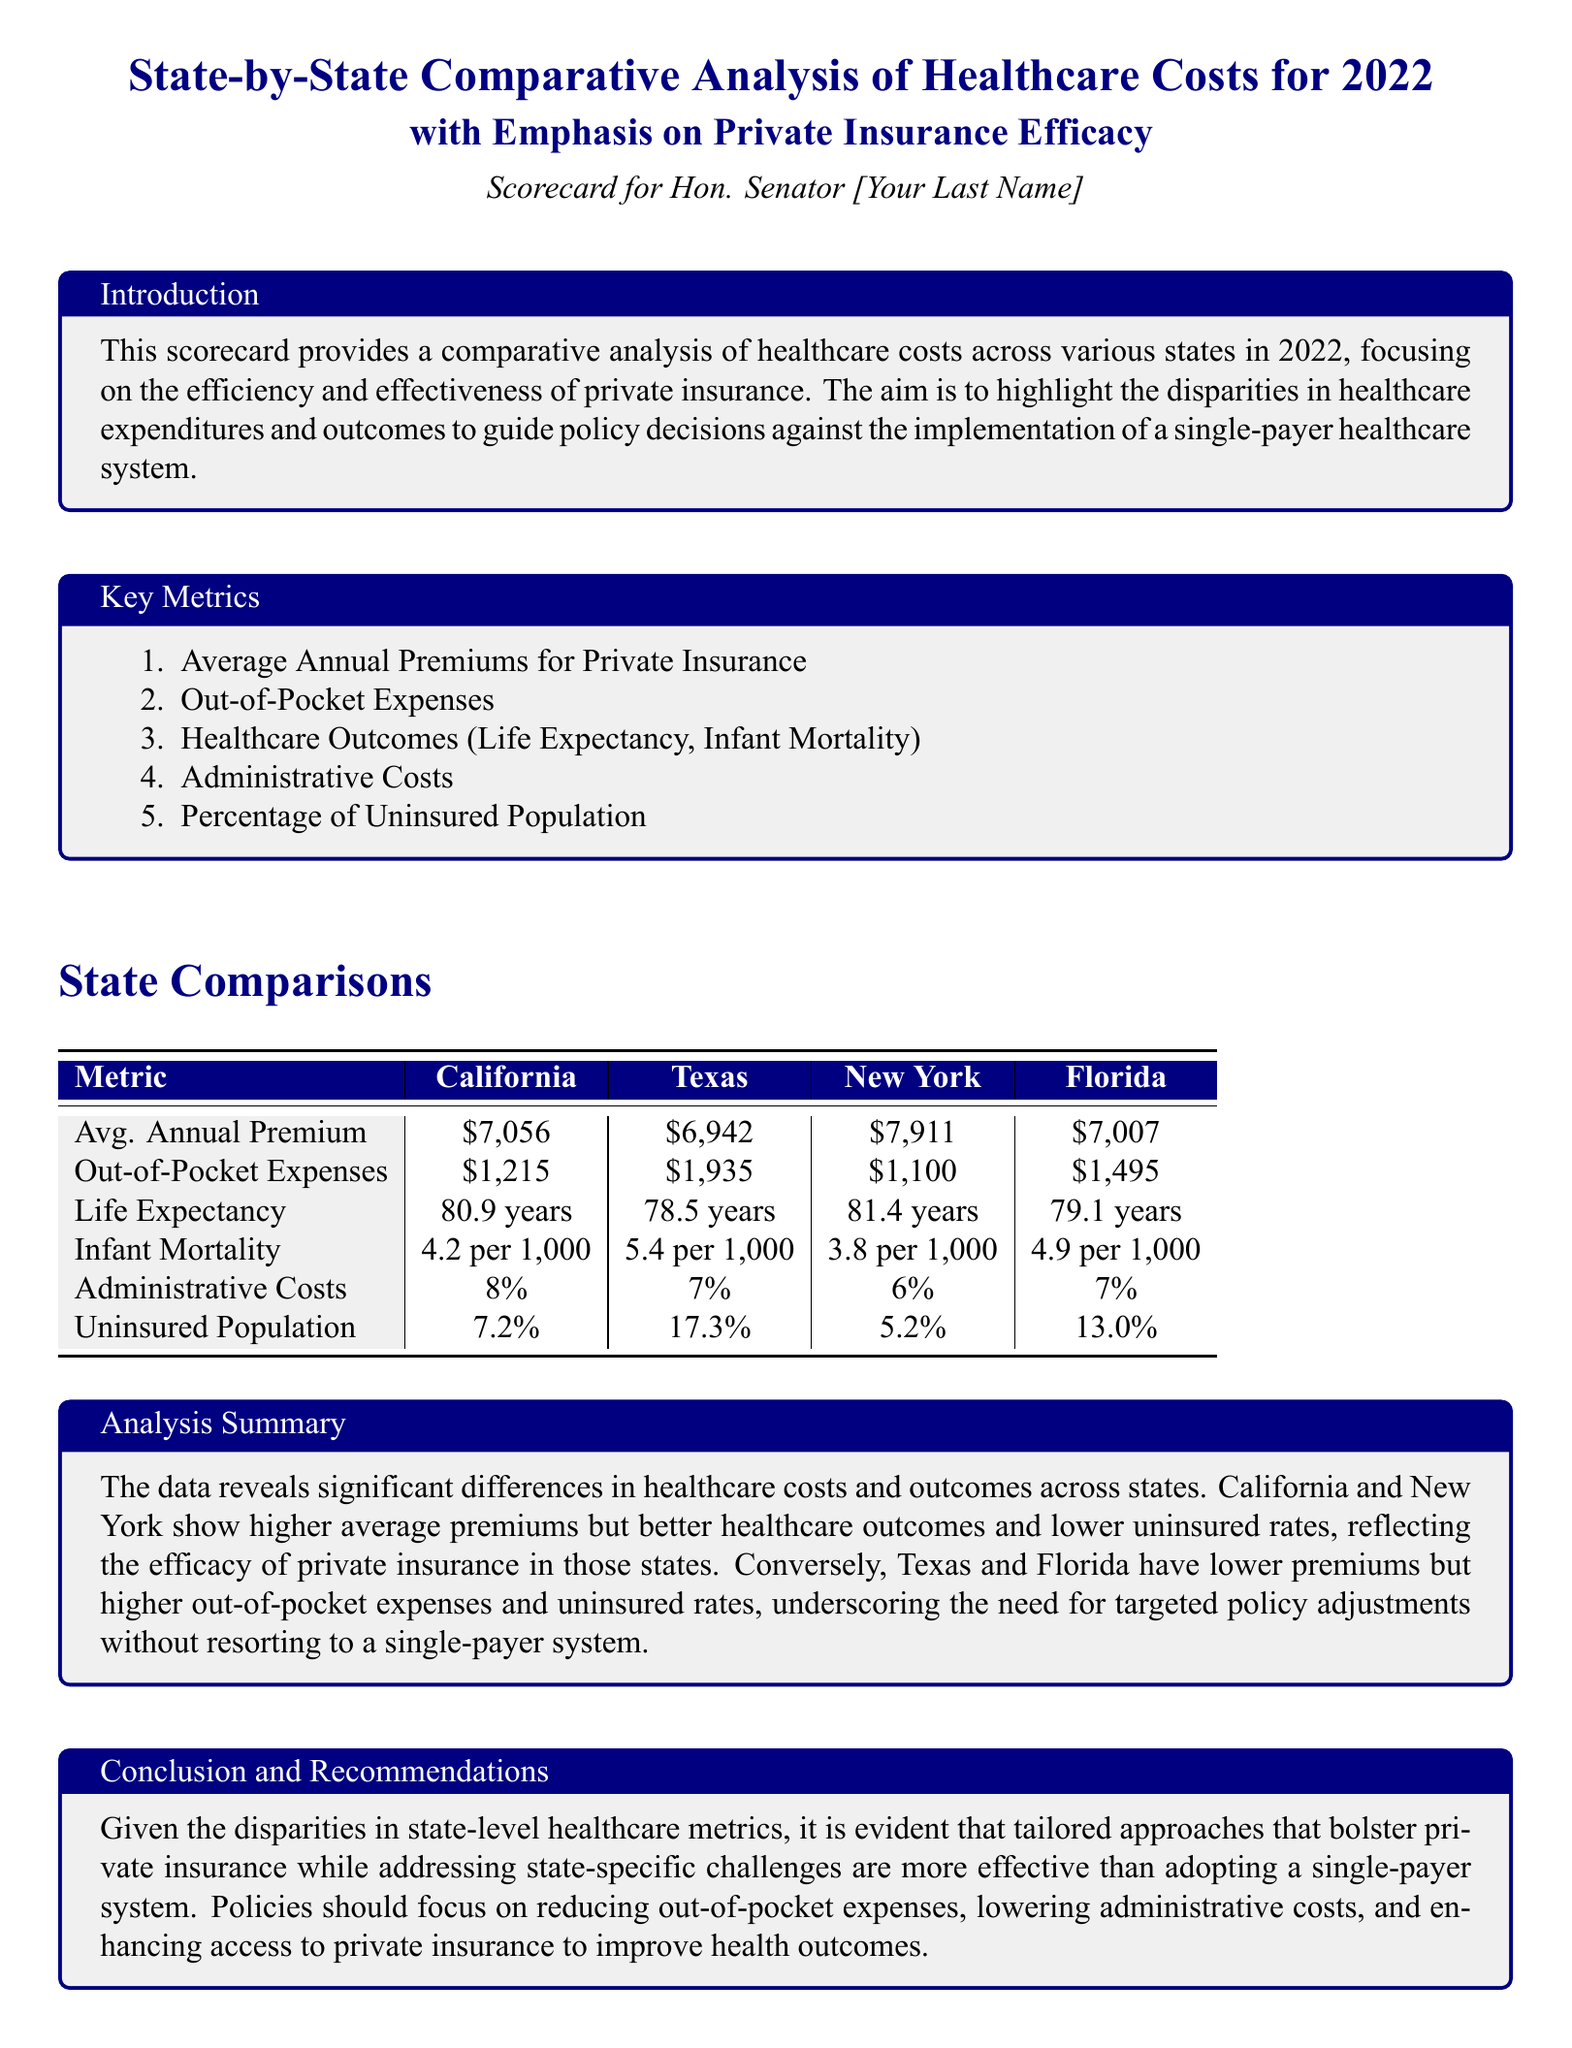What is the average annual premium for private insurance in California? The average annual premium for private insurance in California is specifically stated in the table as $7,056.
Answer: $7,056 What is the out-of-pocket expense for Texas residents? The document lists the out-of-pocket expenses for Texas as $1,935 in the comparative table.
Answer: $1,935 Which state has the highest life expectancy? The analysis summary and table indicate that New York has the highest life expectancy at 81.4 years.
Answer: New York What percentage of the population is uninsured in Florida? The document notes that the uninsured population percentage in Florida is 13.0%, as shown in the table.
Answer: 13.0% Which state has the lowest infant mortality rate? The comparative metrics in the document reveal that New York has the lowest infant mortality rate at 3.8 per 1,000.
Answer: New York What is the range of administrative costs among the listed states? The administrative costs are reported as ranging from 6% to 8% across the states, indicating the variation in expenses.
Answer: 6% to 8% What is the key focus of the analysis summary? The analysis summary emphasizes significant differences in healthcare costs and outcomes, particularly advising against a single-payer system.
Answer: Disparities in healthcare costs and outcomes What are the recommendations regarding the approach to healthcare systems? The conclusion urges for tailored approaches to enhance private insurance rather than adopting a single-payer system.
Answer: Tailored approaches to enhance private insurance Which state shows the highest average out-of-pocket expenses? The data in the document indicates Texas has the highest average out-of-pocket expenses at $1,935.
Answer: Texas 